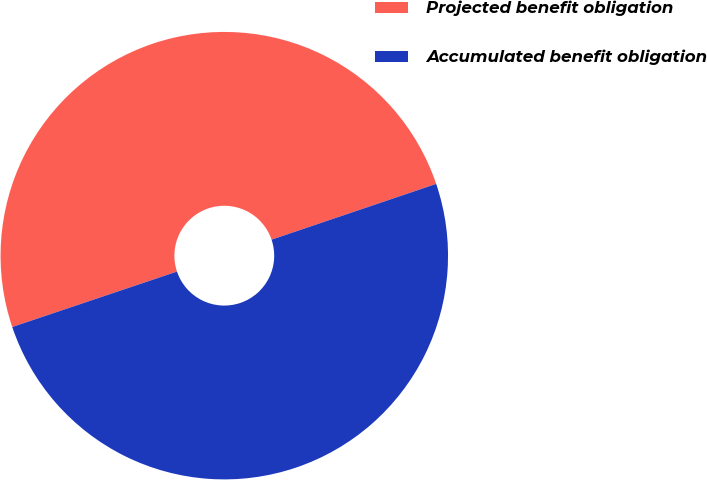Convert chart to OTSL. <chart><loc_0><loc_0><loc_500><loc_500><pie_chart><fcel>Projected benefit obligation<fcel>Accumulated benefit obligation<nl><fcel>49.97%<fcel>50.03%<nl></chart> 